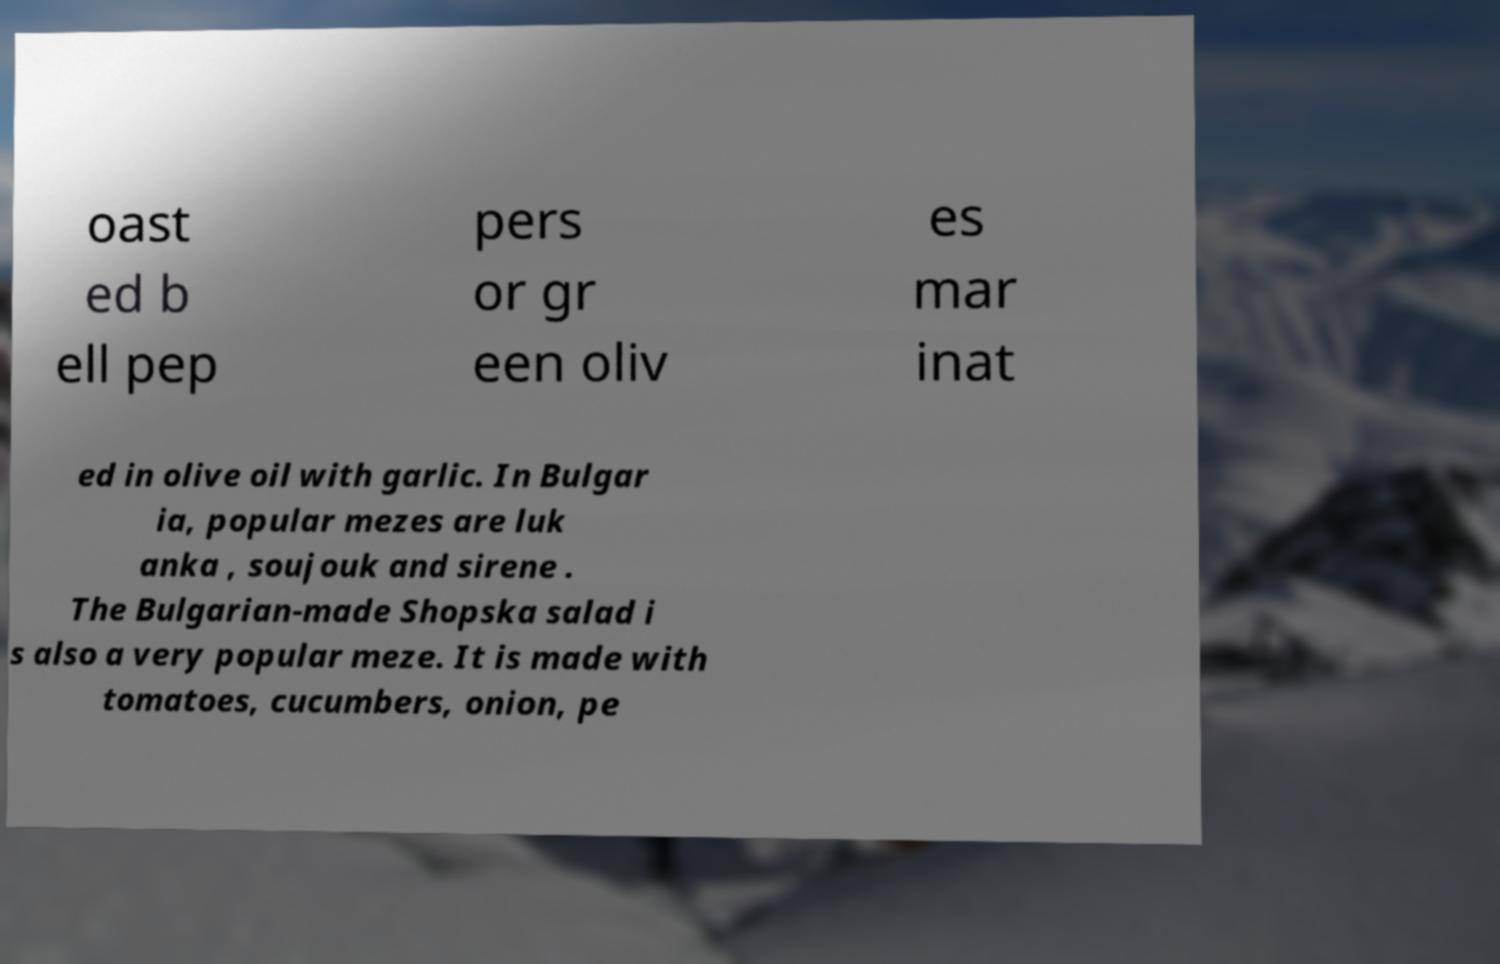Could you extract and type out the text from this image? oast ed b ell pep pers or gr een oliv es mar inat ed in olive oil with garlic. In Bulgar ia, popular mezes are luk anka , soujouk and sirene . The Bulgarian-made Shopska salad i s also a very popular meze. It is made with tomatoes, cucumbers, onion, pe 